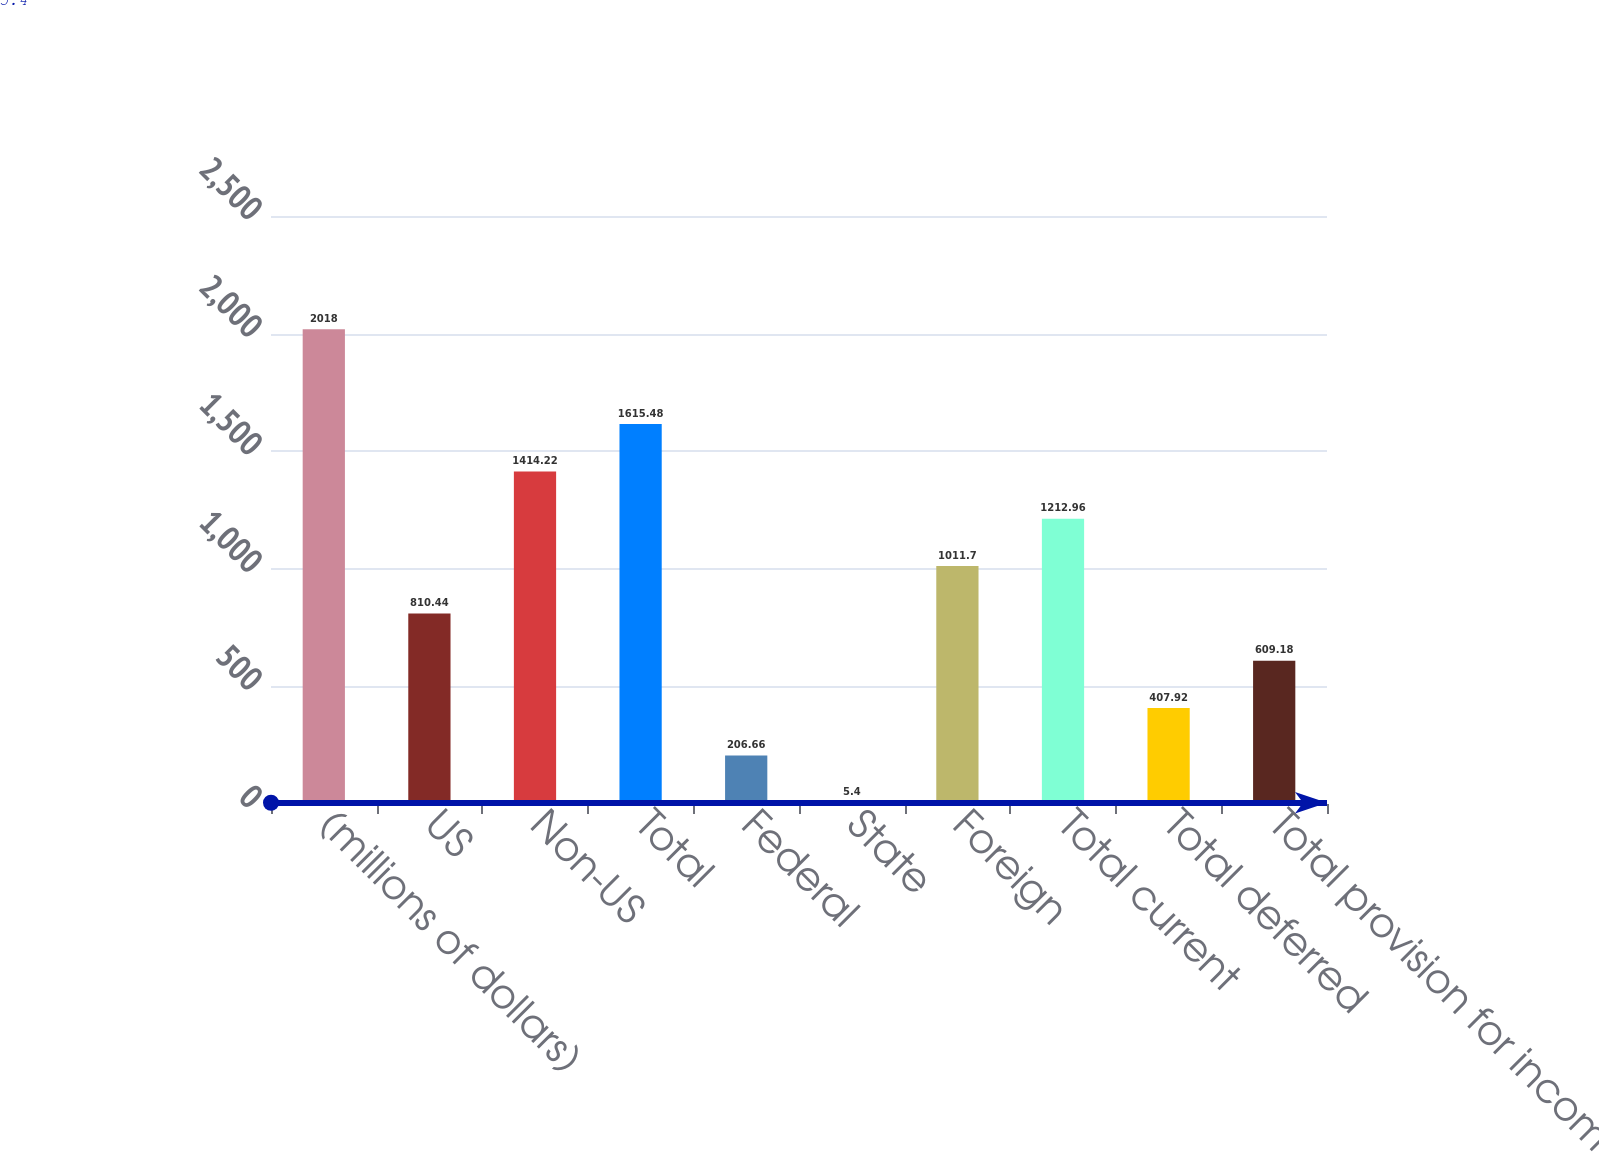<chart> <loc_0><loc_0><loc_500><loc_500><bar_chart><fcel>(millions of dollars)<fcel>US<fcel>Non-US<fcel>Total<fcel>Federal<fcel>State<fcel>Foreign<fcel>Total current<fcel>Total deferred<fcel>Total provision for income<nl><fcel>2018<fcel>810.44<fcel>1414.22<fcel>1615.48<fcel>206.66<fcel>5.4<fcel>1011.7<fcel>1212.96<fcel>407.92<fcel>609.18<nl></chart> 